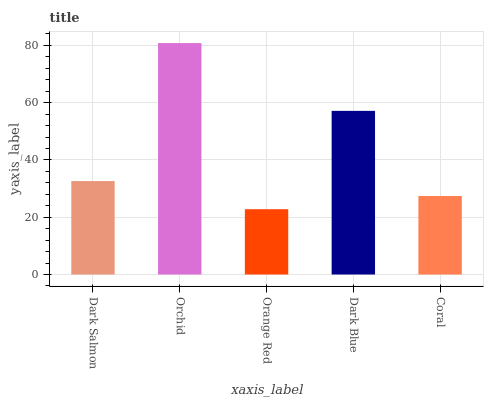Is Orange Red the minimum?
Answer yes or no. Yes. Is Orchid the maximum?
Answer yes or no. Yes. Is Orchid the minimum?
Answer yes or no. No. Is Orange Red the maximum?
Answer yes or no. No. Is Orchid greater than Orange Red?
Answer yes or no. Yes. Is Orange Red less than Orchid?
Answer yes or no. Yes. Is Orange Red greater than Orchid?
Answer yes or no. No. Is Orchid less than Orange Red?
Answer yes or no. No. Is Dark Salmon the high median?
Answer yes or no. Yes. Is Dark Salmon the low median?
Answer yes or no. Yes. Is Orange Red the high median?
Answer yes or no. No. Is Orange Red the low median?
Answer yes or no. No. 